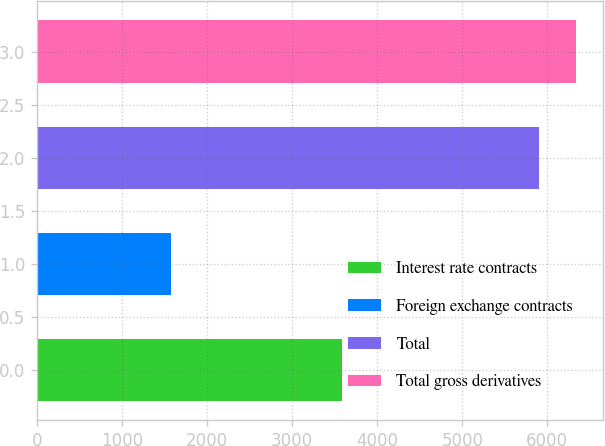Convert chart to OTSL. <chart><loc_0><loc_0><loc_500><loc_500><bar_chart><fcel>Interest rate contracts<fcel>Foreign exchange contracts<fcel>Total<fcel>Total gross derivatives<nl><fcel>3586<fcel>1580<fcel>5904<fcel>6340<nl></chart> 